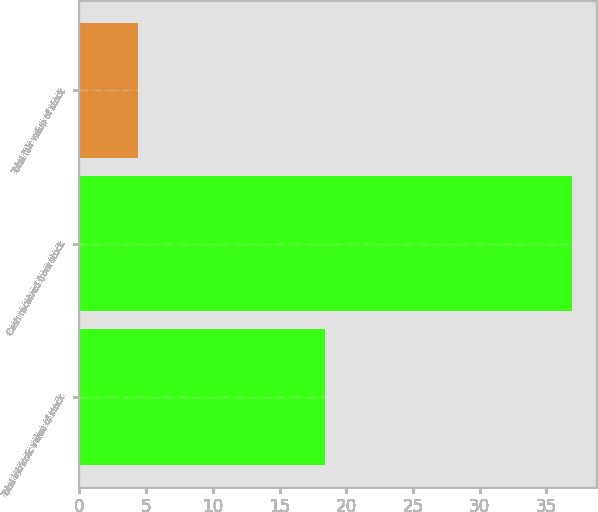Convert chart. <chart><loc_0><loc_0><loc_500><loc_500><bar_chart><fcel>Total intrinsic value of stock<fcel>Cash received from stock<fcel>Total fair value of stock<nl><fcel>18.4<fcel>36.9<fcel>4.4<nl></chart> 